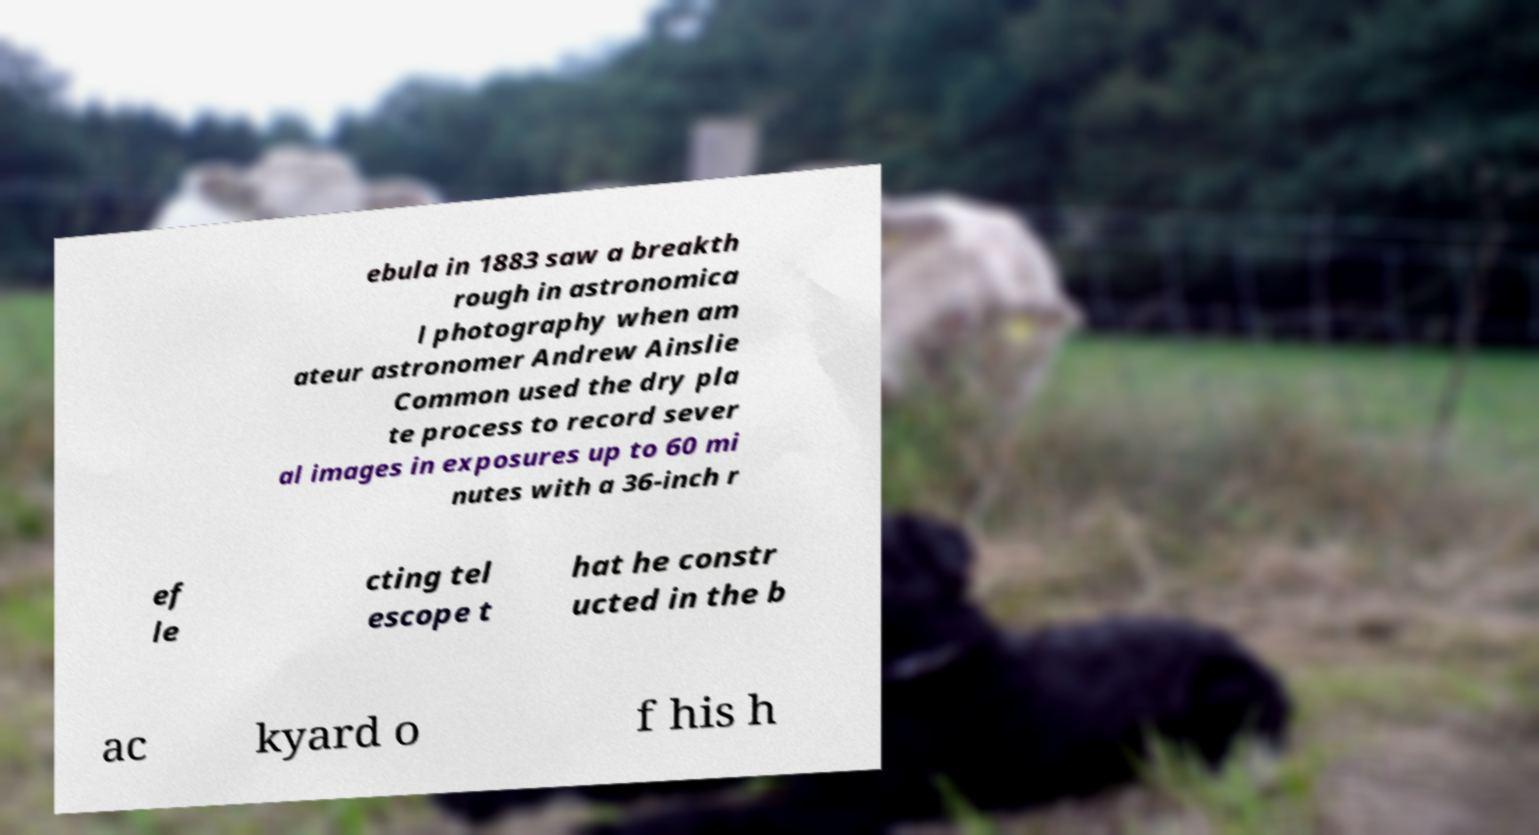Could you extract and type out the text from this image? ebula in 1883 saw a breakth rough in astronomica l photography when am ateur astronomer Andrew Ainslie Common used the dry pla te process to record sever al images in exposures up to 60 mi nutes with a 36-inch r ef le cting tel escope t hat he constr ucted in the b ac kyard o f his h 